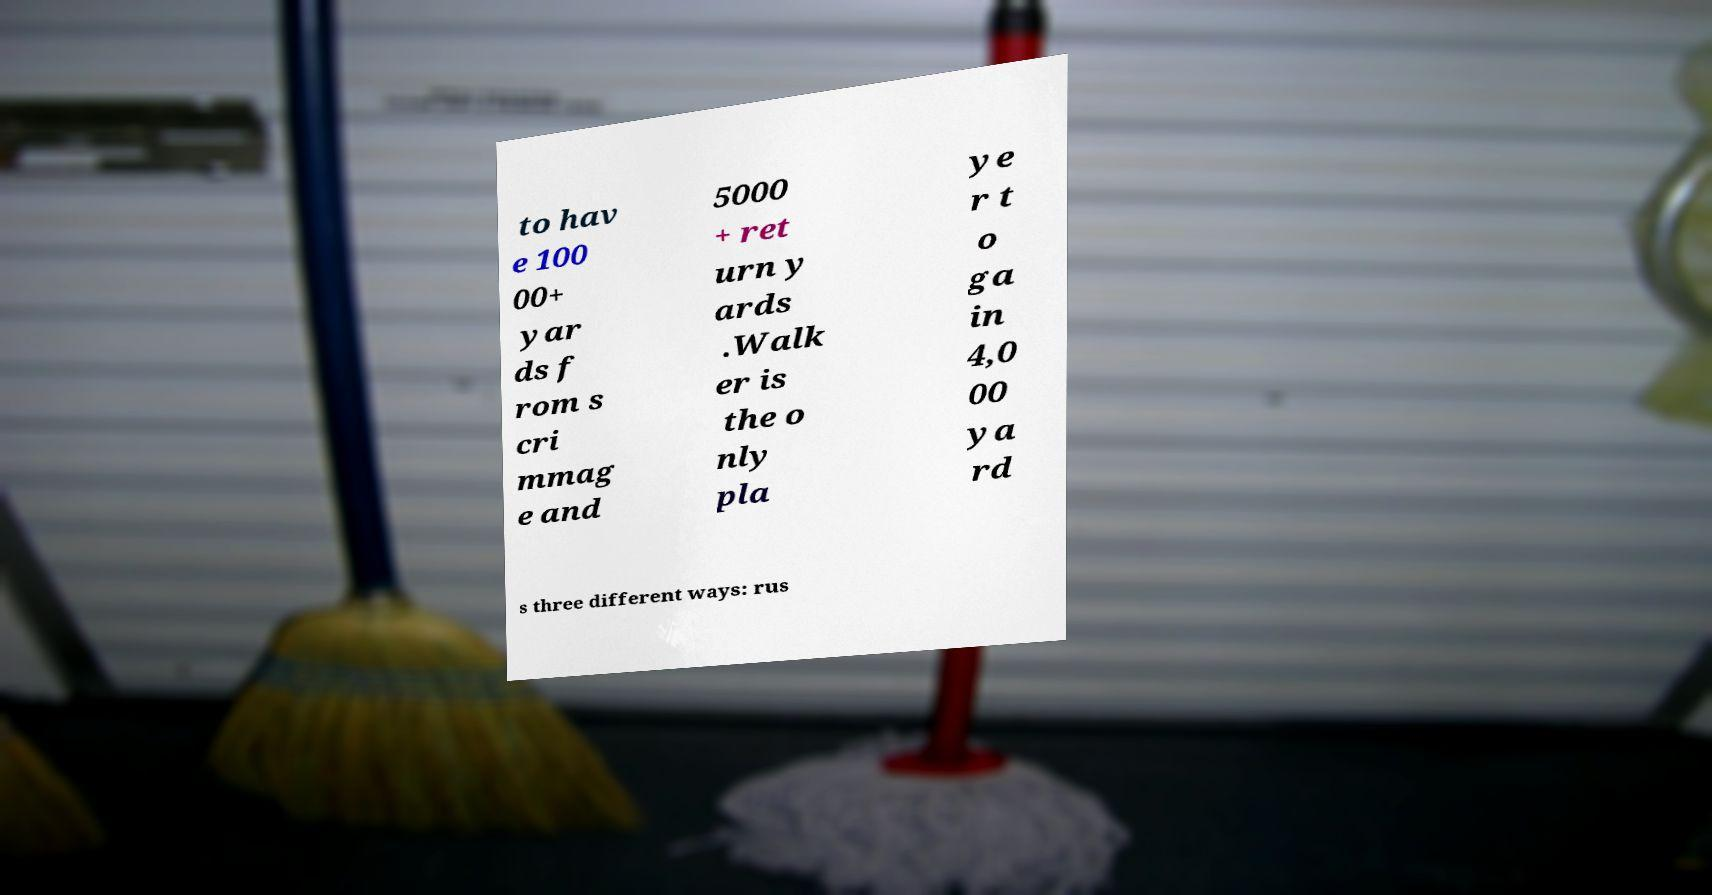Could you extract and type out the text from this image? to hav e 100 00+ yar ds f rom s cri mmag e and 5000 + ret urn y ards .Walk er is the o nly pla ye r t o ga in 4,0 00 ya rd s three different ways: rus 